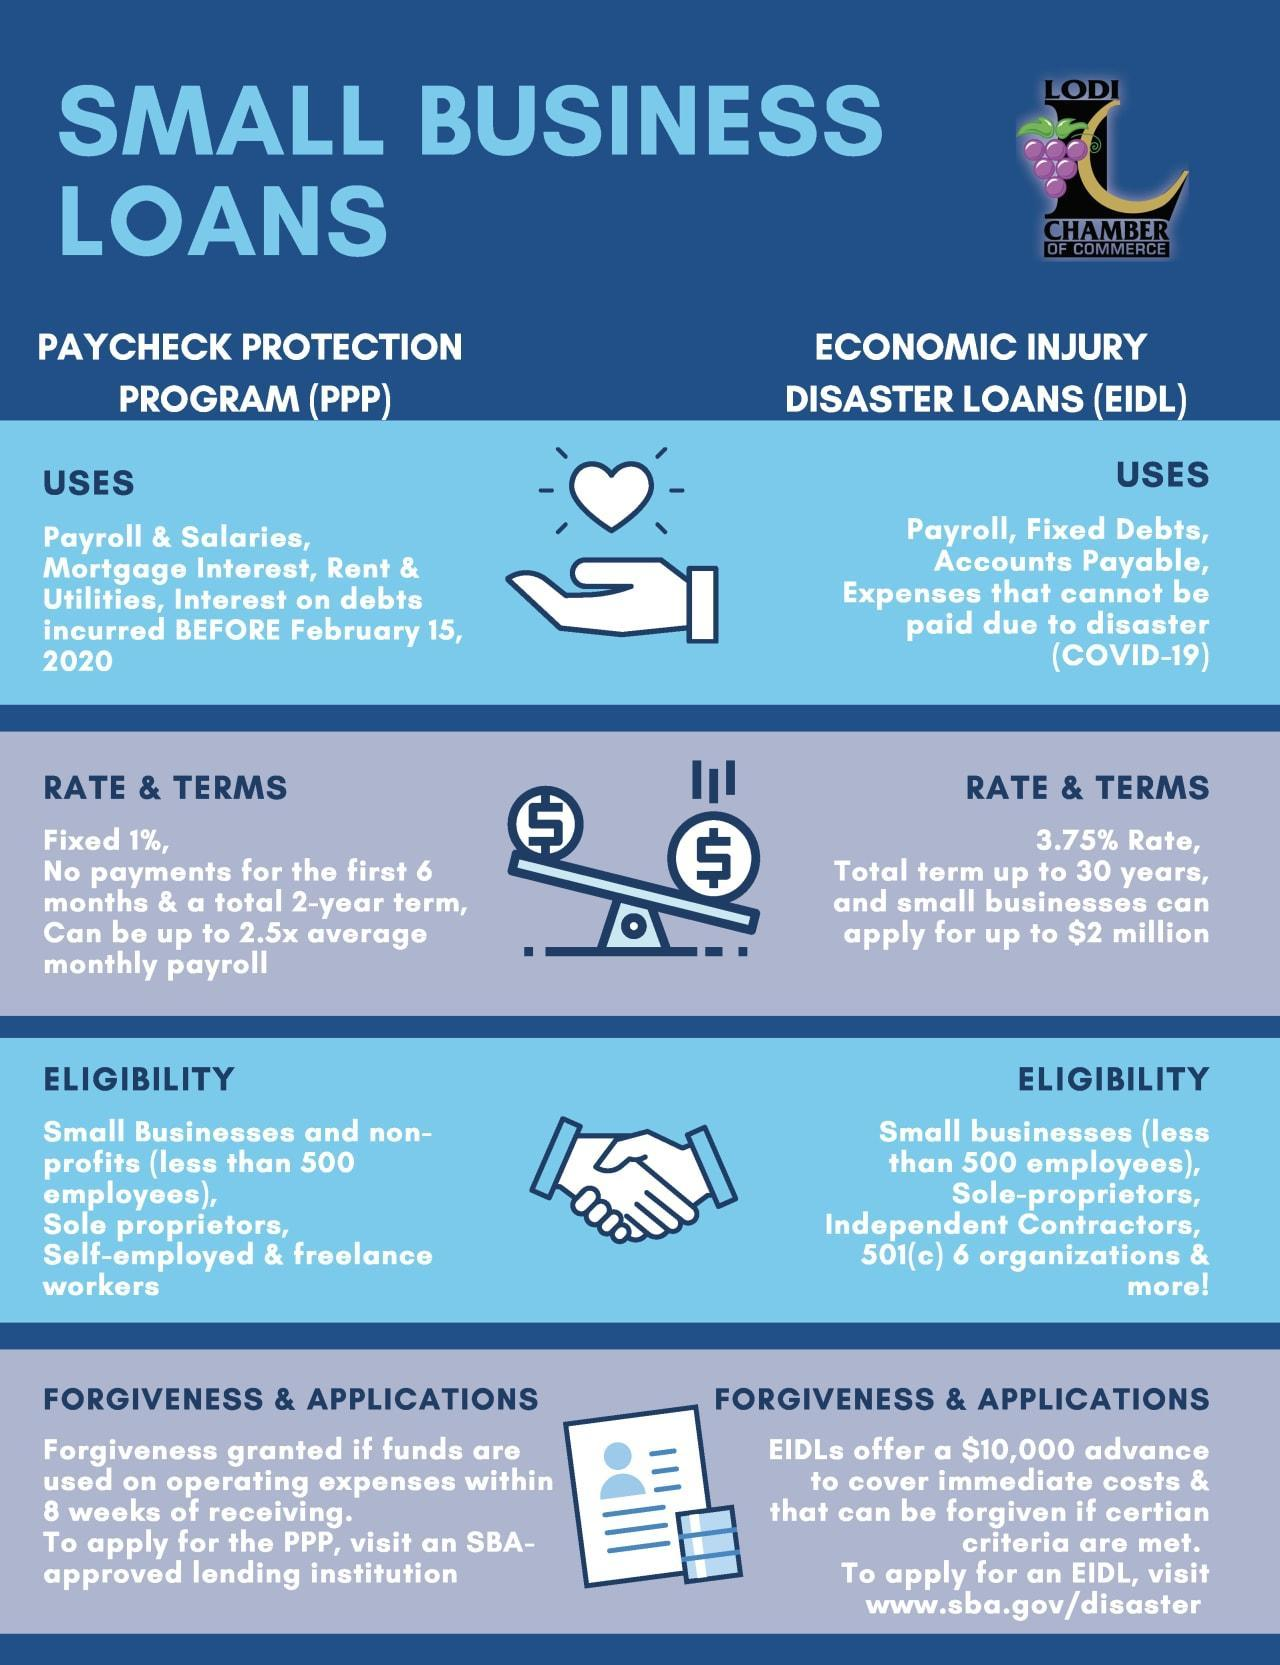How many types of small business loans are in this infographic?
Answer the question with a short phrase. 2 What are the different types of small business loans? Paycheck protection program, Economic injury disaster loans 